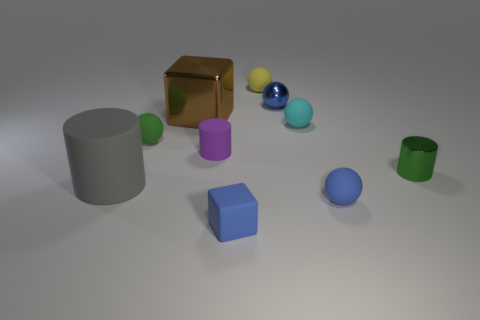Is the number of tiny blue objects behind the big gray matte cylinder less than the number of small green balls?
Your answer should be very brief. No. What number of other objects are there of the same size as the blue metal ball?
Provide a short and direct response. 7. There is a tiny blue rubber thing that is left of the small cyan matte object; does it have the same shape as the blue metal thing?
Offer a very short reply. No. Is the number of small cyan objects that are in front of the green matte sphere greater than the number of small matte cubes?
Ensure brevity in your answer.  No. What is the cylinder that is behind the gray rubber thing and left of the tiny yellow object made of?
Your answer should be compact. Rubber. Is there anything else that is the same shape as the small cyan object?
Offer a terse response. Yes. How many balls are both on the right side of the tiny yellow sphere and left of the large brown shiny block?
Give a very brief answer. 0. What is the small cube made of?
Offer a very short reply. Rubber. Are there an equal number of small cyan balls that are behind the small cyan ball and large blue things?
Give a very brief answer. Yes. What number of blue things are the same shape as the tiny yellow object?
Provide a short and direct response. 2. 